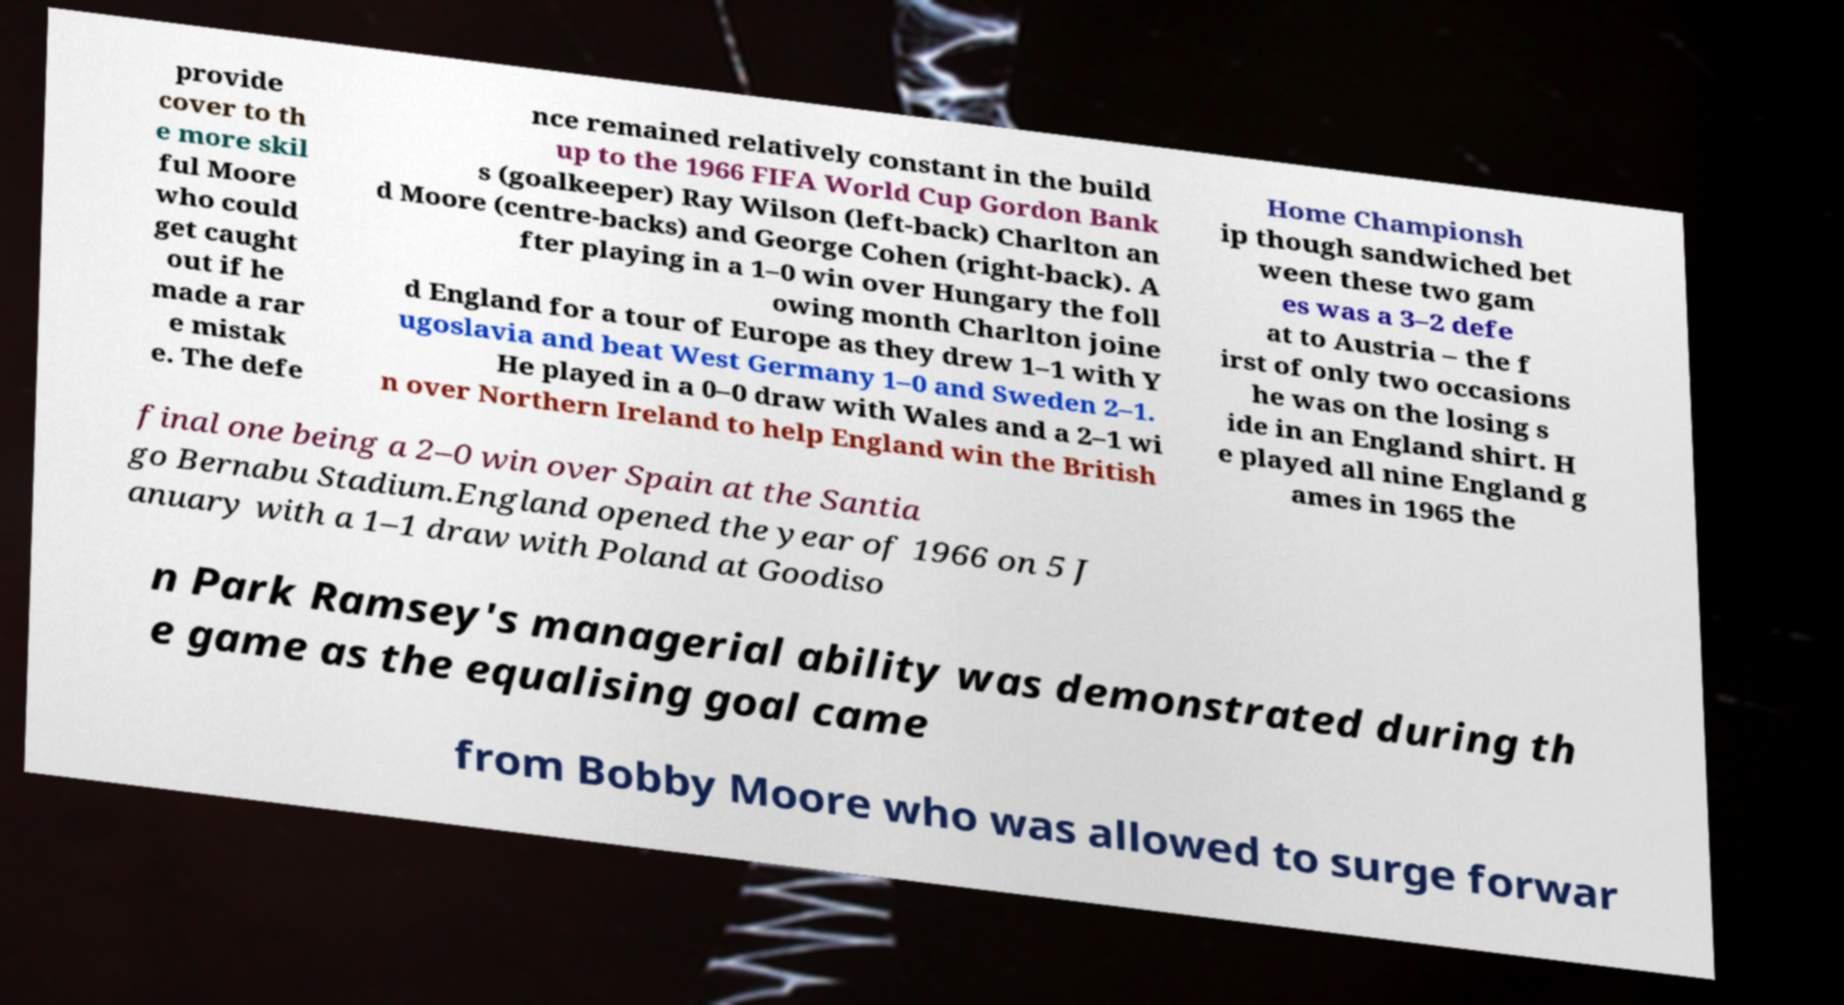Please read and relay the text visible in this image. What does it say? provide cover to th e more skil ful Moore who could get caught out if he made a rar e mistak e. The defe nce remained relatively constant in the build up to the 1966 FIFA World Cup Gordon Bank s (goalkeeper) Ray Wilson (left-back) Charlton an d Moore (centre-backs) and George Cohen (right-back). A fter playing in a 1–0 win over Hungary the foll owing month Charlton joine d England for a tour of Europe as they drew 1–1 with Y ugoslavia and beat West Germany 1–0 and Sweden 2–1. He played in a 0–0 draw with Wales and a 2–1 wi n over Northern Ireland to help England win the British Home Championsh ip though sandwiched bet ween these two gam es was a 3–2 defe at to Austria – the f irst of only two occasions he was on the losing s ide in an England shirt. H e played all nine England g ames in 1965 the final one being a 2–0 win over Spain at the Santia go Bernabu Stadium.England opened the year of 1966 on 5 J anuary with a 1–1 draw with Poland at Goodiso n Park Ramsey's managerial ability was demonstrated during th e game as the equalising goal came from Bobby Moore who was allowed to surge forwar 